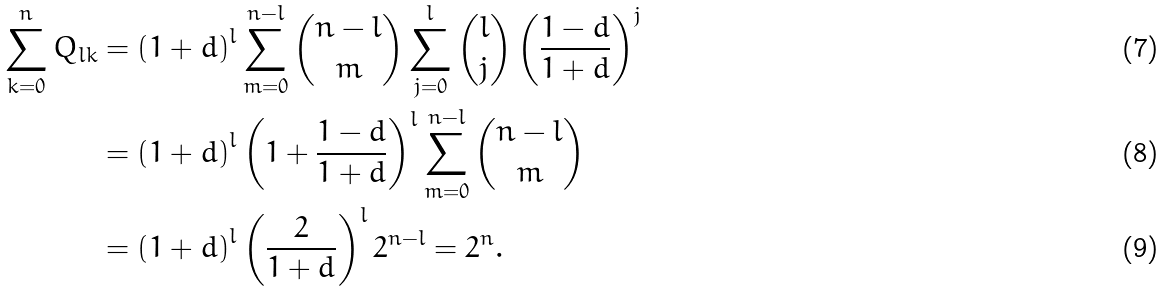<formula> <loc_0><loc_0><loc_500><loc_500>\sum _ { k = 0 } ^ { n } Q _ { l k } & = \left ( 1 + d \right ) ^ { l } \sum _ { m = 0 } ^ { n - l } \binom { n - l } { m } \sum _ { j = 0 } ^ { l } \binom { l } { j } \left ( \frac { 1 - d } { 1 + d } \right ) ^ { j } \\ & = \left ( 1 + d \right ) ^ { l } \left ( 1 + \frac { 1 - d } { 1 + d } \right ) ^ { l } \sum _ { m = 0 } ^ { n - l } \binom { n - l } { m } \\ & = \left ( 1 + d \right ) ^ { l } \left ( \frac { 2 } { 1 + d } \right ) ^ { l } 2 ^ { n - l } = 2 ^ { n } .</formula> 